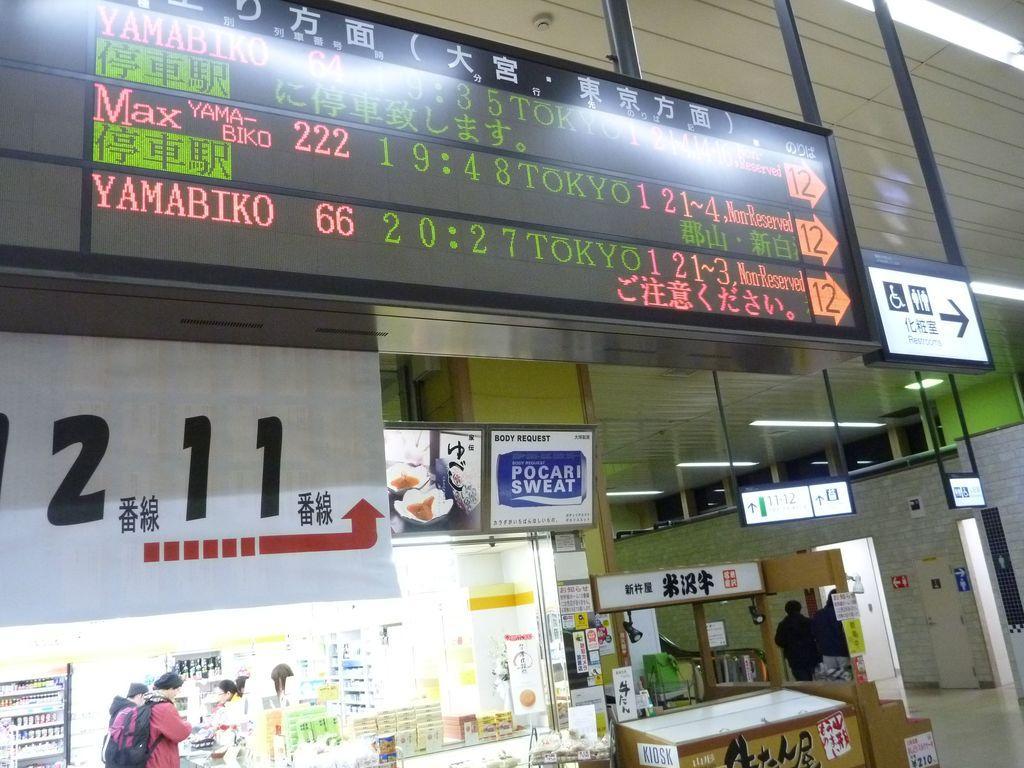Could you give a brief overview of what you see in this image? In this picture we can see the mall. At the top we can see the screen. In the bottom left corner there are two persons were standing near to the table, beside them we can see many bottles on the racks. On the left we can see the posters. At the bottom there are two persons were wearing black dress and there are walking near to the door. On the right there is a sign board. In the top right corner we can see the tube lights at the roof. 